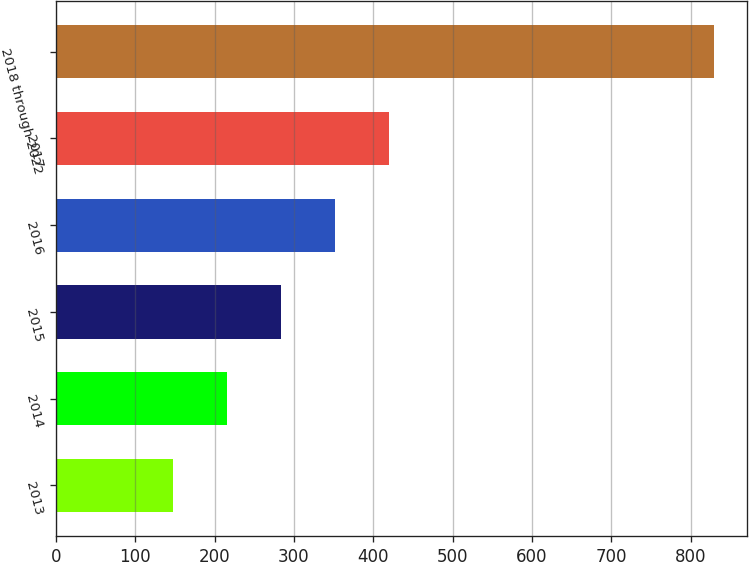<chart> <loc_0><loc_0><loc_500><loc_500><bar_chart><fcel>2013<fcel>2014<fcel>2015<fcel>2016<fcel>2017<fcel>2018 through 2022<nl><fcel>147<fcel>215.2<fcel>283.4<fcel>351.6<fcel>419.8<fcel>829<nl></chart> 